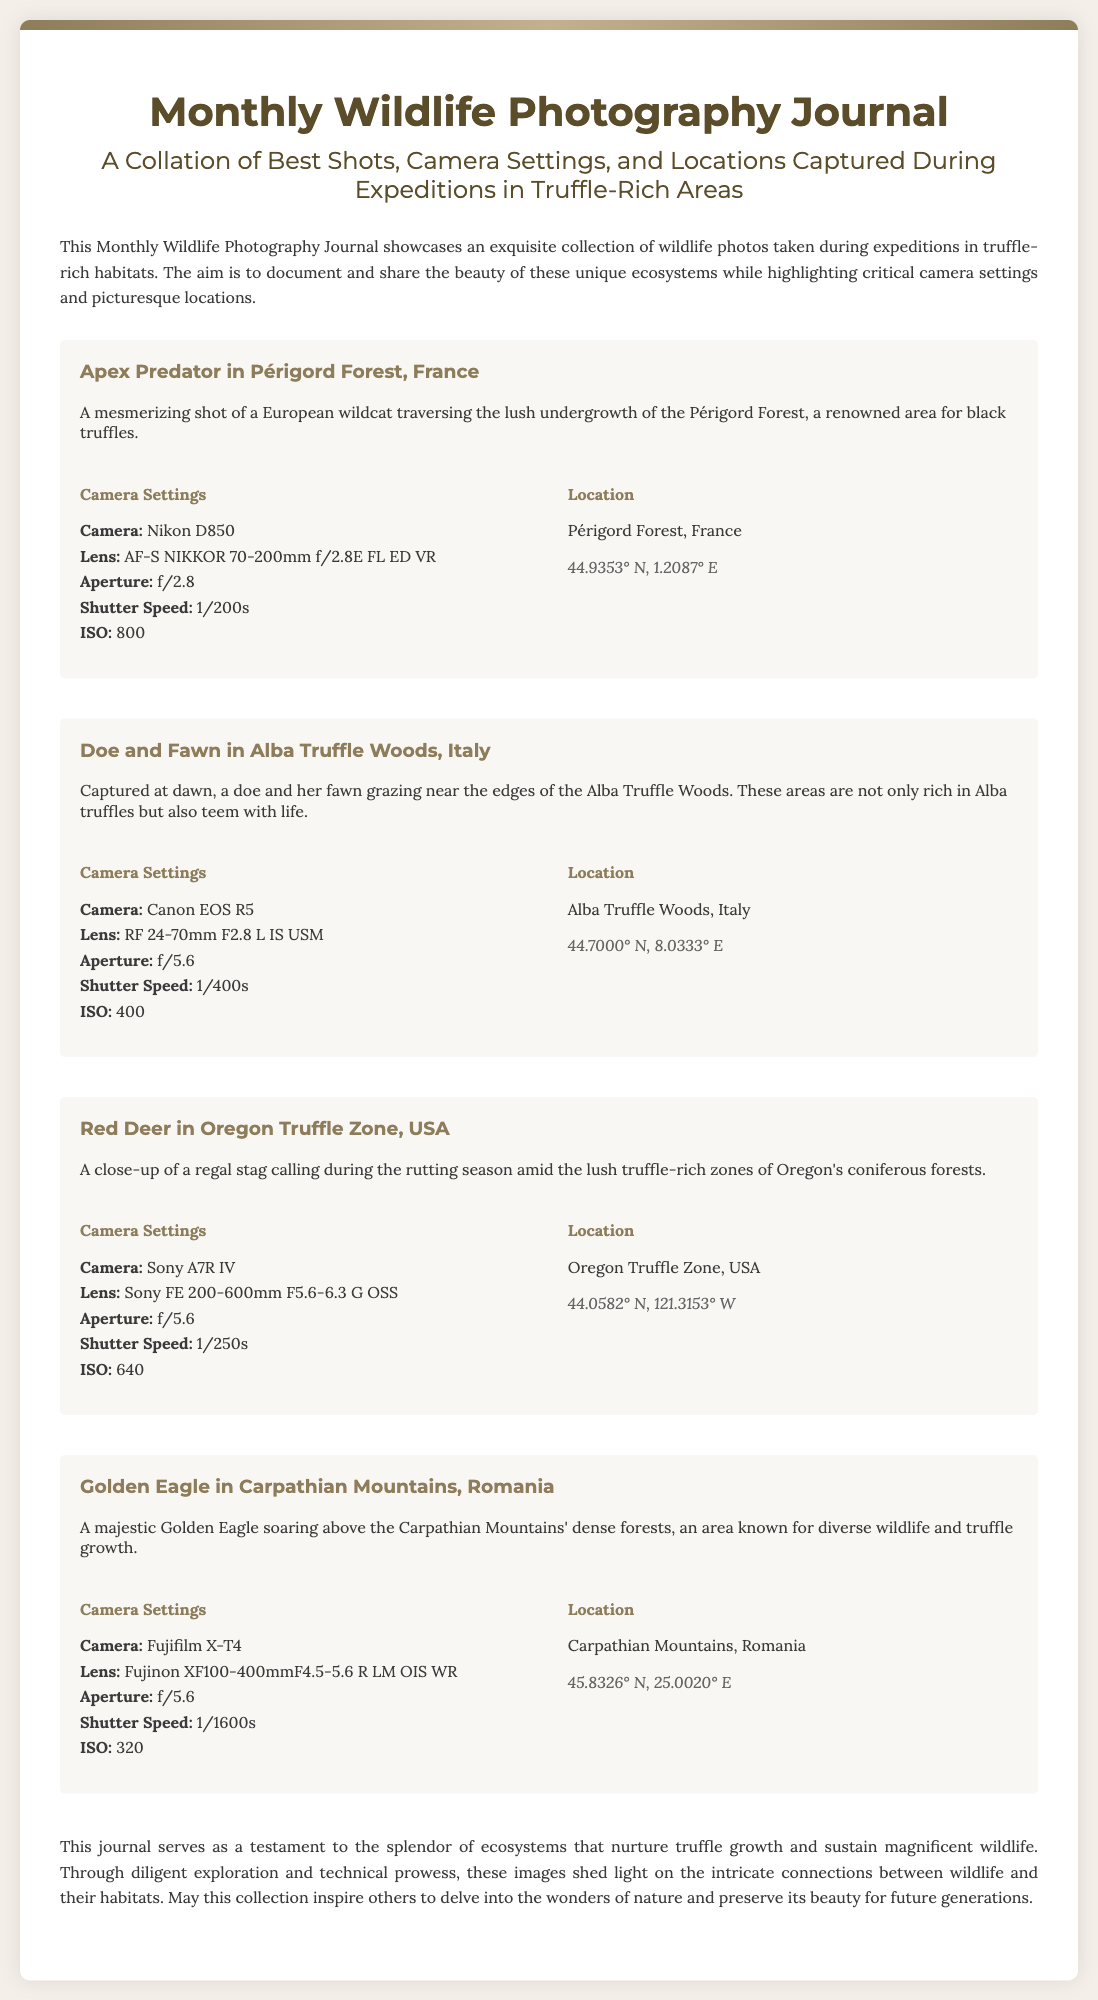What is the title of the journal? The title is prominently displayed at the top of the document, which states "Monthly Wildlife Photography Journal".
Answer: Monthly Wildlife Photography Journal Who is the subject of the first photo entry? The first photo entry features a specific animal, noted in the description as a "European wildcat".
Answer: European wildcat What is the aperture used for the photo of the Doe and Fawn? The aperture is provided in the camera settings section for that particular photo entry, specified as "f/5.6".
Answer: f/5.6 In which country is the Oregon Truffle Zone located? The location information indicates that the Oregon Truffle Zone is in "USA".
Answer: USA What camera was used to capture the Golden Eagle photo? The camera used is listed in the settings for the Golden Eagle photo entry, which is "Fujifilm X-T4".
Answer: Fujifilm X-T4 Which truffle-rich area is highlighted for diverse wildlife? The description for the Golden Eagle also mentions this area, identifying it as "Carpathian Mountains".
Answer: Carpathian Mountains How many photo entries are included in the journal? The document lists four distinct photo entries throughout the content.
Answer: Four What is the geographic coordinate format presented in the document? The coordinates are provided in a specific style that includes degrees and directional indicators, such as "44.9353° N".
Answer: Degrees and directional indicators 